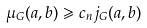<formula> <loc_0><loc_0><loc_500><loc_500>\mu _ { G } ( a , b ) \geqslant c _ { n } j _ { G } ( a , b )</formula> 